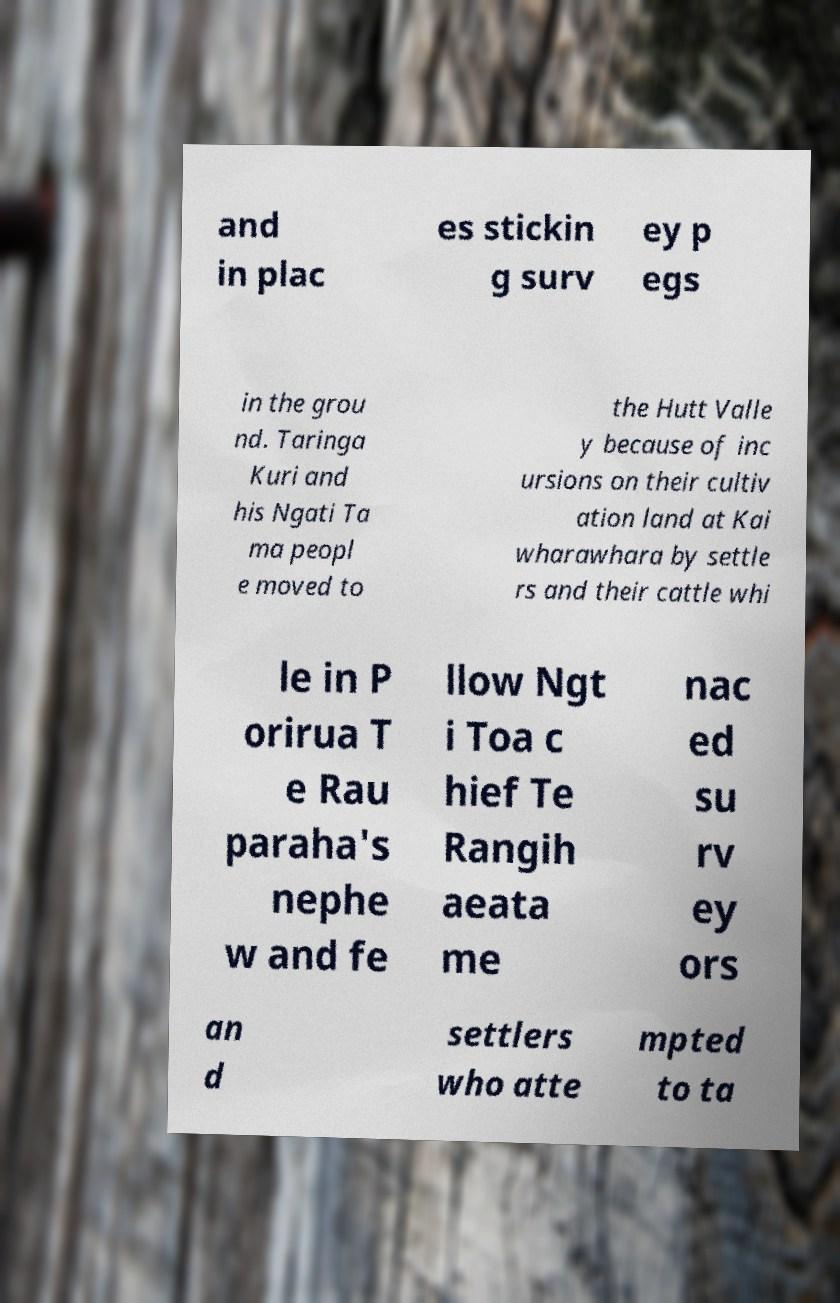Could you assist in decoding the text presented in this image and type it out clearly? and in plac es stickin g surv ey p egs in the grou nd. Taringa Kuri and his Ngati Ta ma peopl e moved to the Hutt Valle y because of inc ursions on their cultiv ation land at Kai wharawhara by settle rs and their cattle whi le in P orirua T e Rau paraha's nephe w and fe llow Ngt i Toa c hief Te Rangih aeata me nac ed su rv ey ors an d settlers who atte mpted to ta 